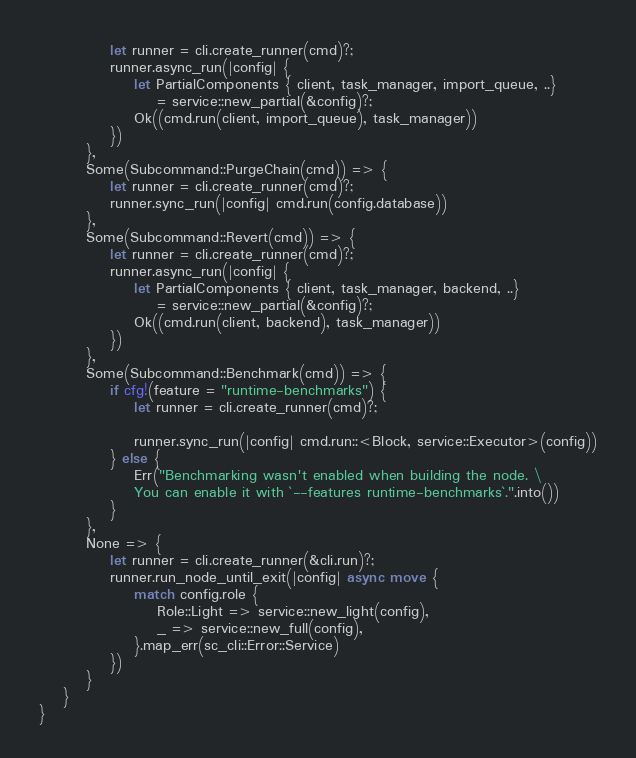<code> <loc_0><loc_0><loc_500><loc_500><_Rust_>			let runner = cli.create_runner(cmd)?;
			runner.async_run(|config| {
				let PartialComponents { client, task_manager, import_queue, ..}
					= service::new_partial(&config)?;
				Ok((cmd.run(client, import_queue), task_manager))
			})
		},
		Some(Subcommand::PurgeChain(cmd)) => {
			let runner = cli.create_runner(cmd)?;
			runner.sync_run(|config| cmd.run(config.database))
		},
		Some(Subcommand::Revert(cmd)) => {
			let runner = cli.create_runner(cmd)?;
			runner.async_run(|config| {
				let PartialComponents { client, task_manager, backend, ..}
					= service::new_partial(&config)?;
				Ok((cmd.run(client, backend), task_manager))
			})
		},
		Some(Subcommand::Benchmark(cmd)) => {
			if cfg!(feature = "runtime-benchmarks") {
				let runner = cli.create_runner(cmd)?;

				runner.sync_run(|config| cmd.run::<Block, service::Executor>(config))
			} else {
				Err("Benchmarking wasn't enabled when building the node. \
				You can enable it with `--features runtime-benchmarks`.".into())
			}
		},
		None => {
			let runner = cli.create_runner(&cli.run)?;
			runner.run_node_until_exit(|config| async move {
				match config.role {
					Role::Light => service::new_light(config),
					_ => service::new_full(config),
				}.map_err(sc_cli::Error::Service)
			})
		}
	}
}
</code> 